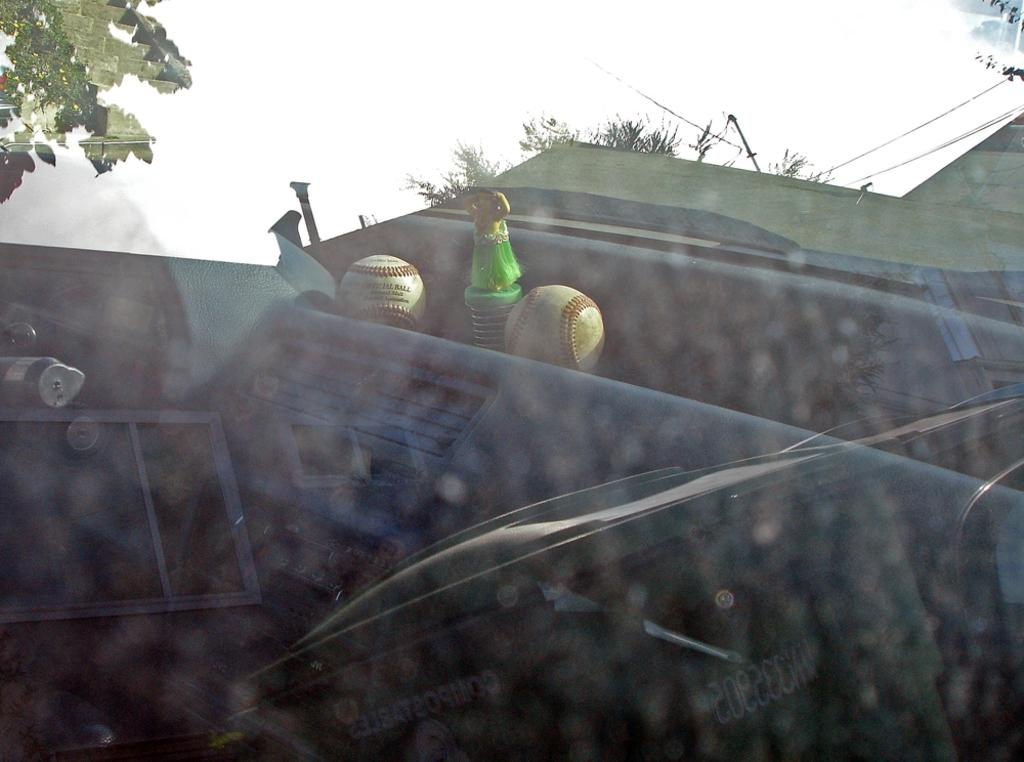What type of structure is visible in the image? There is a roof in the image. What equipment can be seen in the image? There are booms and an object with a spring and brush in the image. What type of vegetation is visible in the image? There are trees visible in the image. What part of a vehicle is depicted in the image? There is a car dashboard in the image. What type of reward can be seen hanging from the trees in the image? There are no rewards hanging from the trees in the image; only trees are visible. What process is being carried out by the trains in the image? There are no trains present in the image, so no process can be observed. 